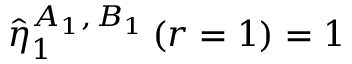<formula> <loc_0><loc_0><loc_500><loc_500>\hat { \eta } _ { 1 } ^ { A _ { 1 } , \, B _ { 1 } } \left ( r = 1 \right ) = 1</formula> 